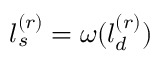Convert formula to latex. <formula><loc_0><loc_0><loc_500><loc_500>l _ { s } ^ { ( r ) } = \omega ( l _ { d } ^ { ( r ) } )</formula> 